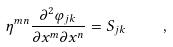<formula> <loc_0><loc_0><loc_500><loc_500>\eta ^ { m n } \frac { \partial ^ { 2 } \varphi _ { j k } } { \partial x ^ { m } \partial x ^ { n } } = S _ { j k } \quad ,</formula> 